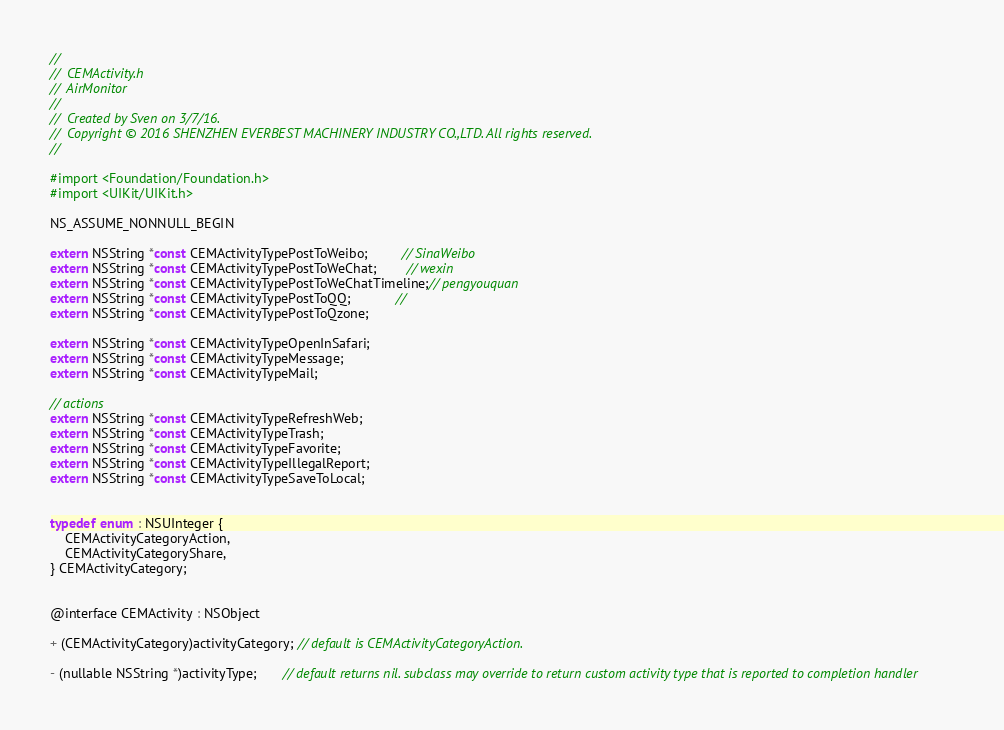Convert code to text. <code><loc_0><loc_0><loc_500><loc_500><_C_>//
//  CEMActivity.h
//  AirMonitor
//
//  Created by Sven on 3/7/16.
//  Copyright © 2016 SHENZHEN EVERBEST MACHINERY INDUSTRY CO.,LTD. All rights reserved.
//

#import <Foundation/Foundation.h>
#import <UIKit/UIKit.h>

NS_ASSUME_NONNULL_BEGIN

extern NSString *const CEMActivityTypePostToWeibo;         // SinaWeibo
extern NSString *const CEMActivityTypePostToWeChat;        // wexin
extern NSString *const CEMActivityTypePostToWeChatTimeline;// pengyouquan
extern NSString *const CEMActivityTypePostToQQ;            //
extern NSString *const CEMActivityTypePostToQzone;

extern NSString *const CEMActivityTypeOpenInSafari;
extern NSString *const CEMActivityTypeMessage;
extern NSString *const CEMActivityTypeMail;

// actions
extern NSString *const CEMActivityTypeRefreshWeb;
extern NSString *const CEMActivityTypeTrash;
extern NSString *const CEMActivityTypeFavorite;
extern NSString *const CEMActivityTypeIllegalReport;
extern NSString *const CEMActivityTypeSaveToLocal;


typedef enum : NSUInteger {
    CEMActivityCategoryAction,
    CEMActivityCategoryShare,
} CEMActivityCategory;


@interface CEMActivity : NSObject

+ (CEMActivityCategory)activityCategory; // default is CEMActivityCategoryAction.

- (nullable NSString *)activityType;       // default returns nil. subclass may override to return custom activity type that is reported to completion handler</code> 